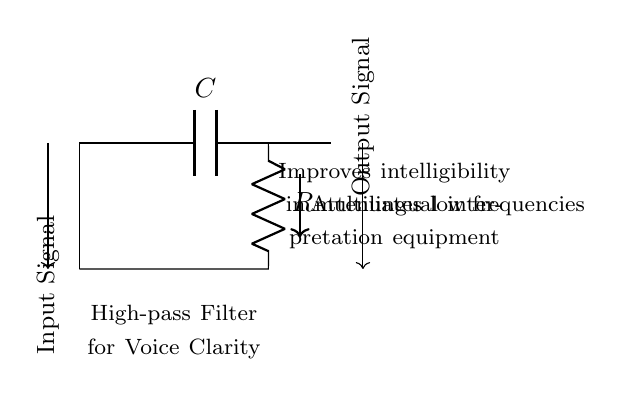What components are in this high-pass filter? The circuit consists of a capacitor (C) and a resistor (R). These components are essential for the operation of a high-pass filter, allowing certain frequencies to pass while blocking others.
Answer: Capacitor, Resistor What is the function of the capacitor in this circuit? The capacitor allows high-frequency signals to pass through while blocking low-frequency signals. This characteristic is crucial in a high-pass filter for improving voice clarity by reducing bass sounds that may distort the main audio.
Answer: Allows high frequencies What does the output signal represent in this circuit? The output signal is the result of filtering the input signal, where low-frequency components are attenuated, improving voice clarity for better intelligibility.
Answer: Filtered audio What frequencies does this high-pass filter attenuate? The high-pass filter attenuates low frequencies, enabling it to focus on higher frequencies which carry important information for intelligibility, especially in multilingual contexts.
Answer: Low frequencies How does this circuit improve voice clarity for multilingual interpretation? By attenuating low frequencies, the filter enhances the clarity of higher frequency sounds, such as speech, which is essential for effective communication in multilingual interpretation scenarios.
Answer: Improves clarity What type of filter is represented by this circuit? This circuit is a high-pass filter, which is specifically designed to allow high-frequency signals to pass while blocking low-frequency signals, making it ideal for voice applications.
Answer: High-pass filter 